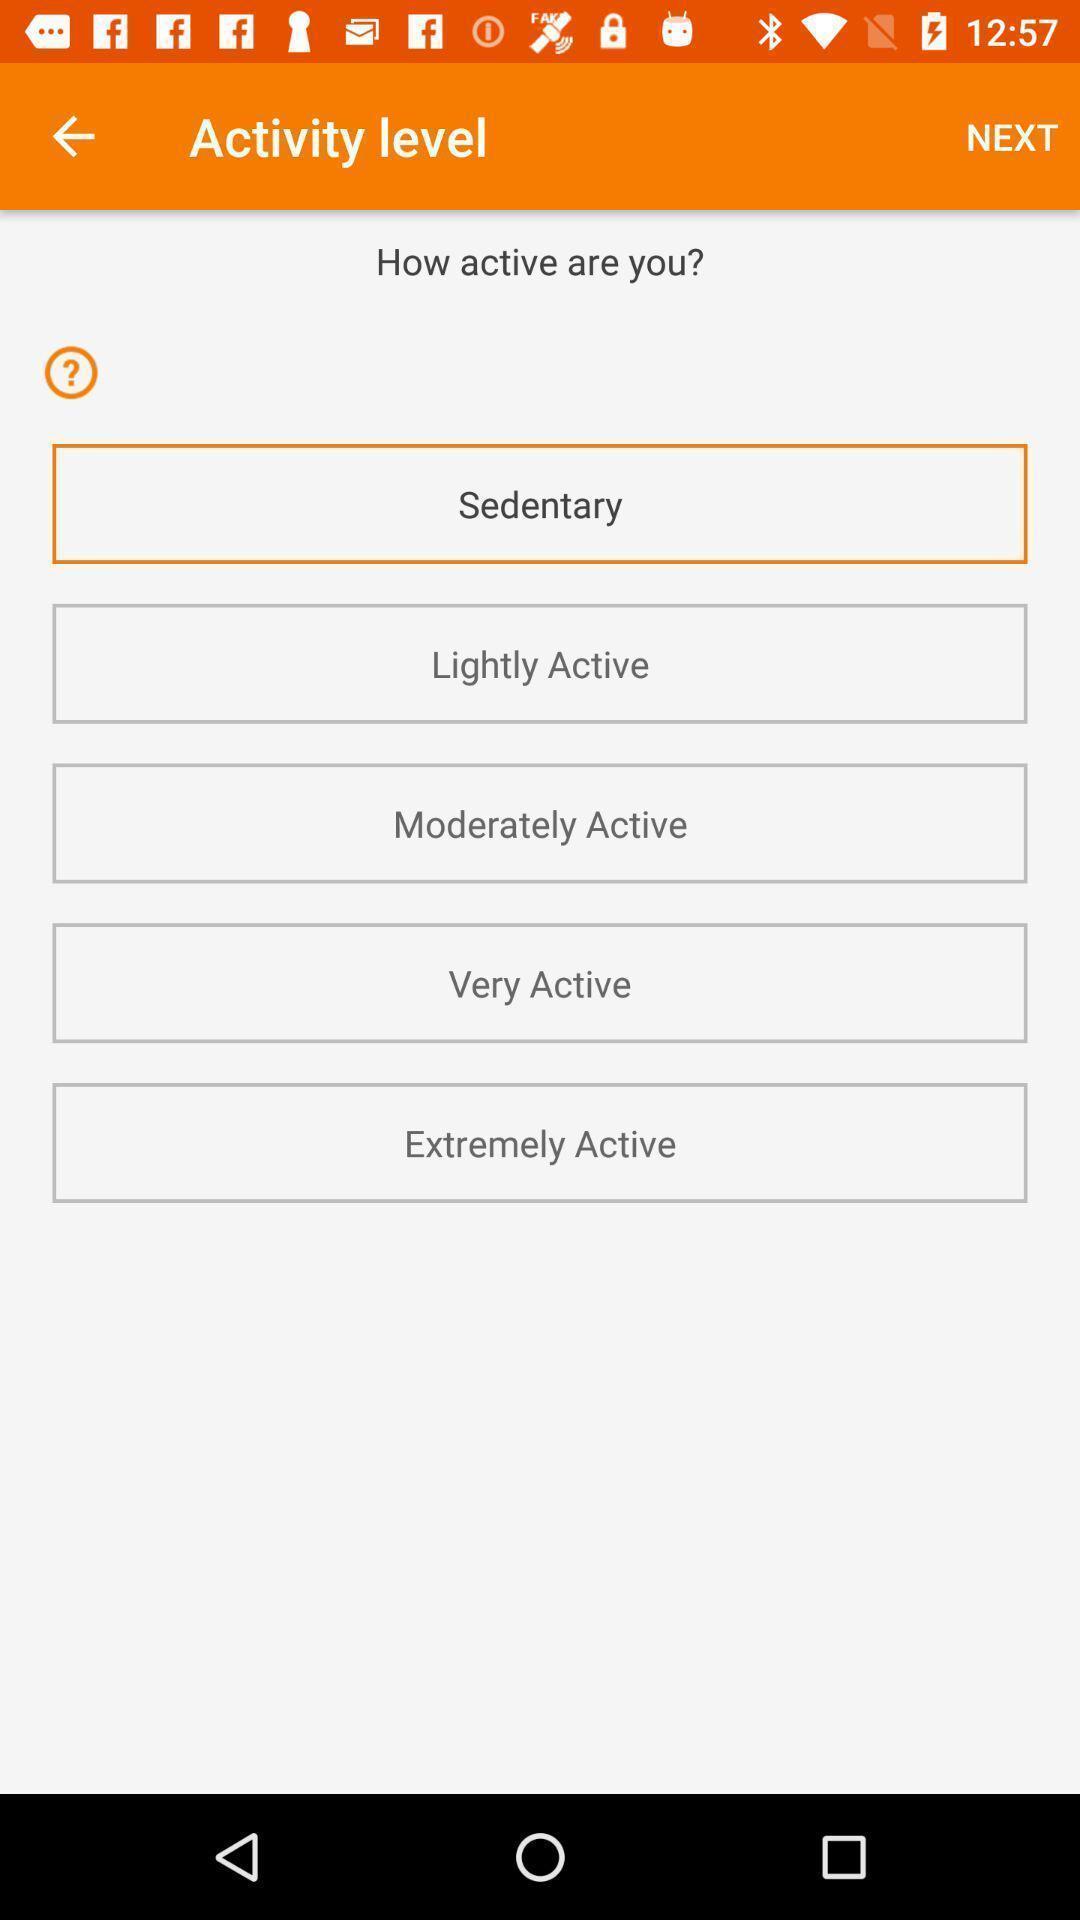Explain the elements present in this screenshot. Screen shows activity level details in a fitness app. 